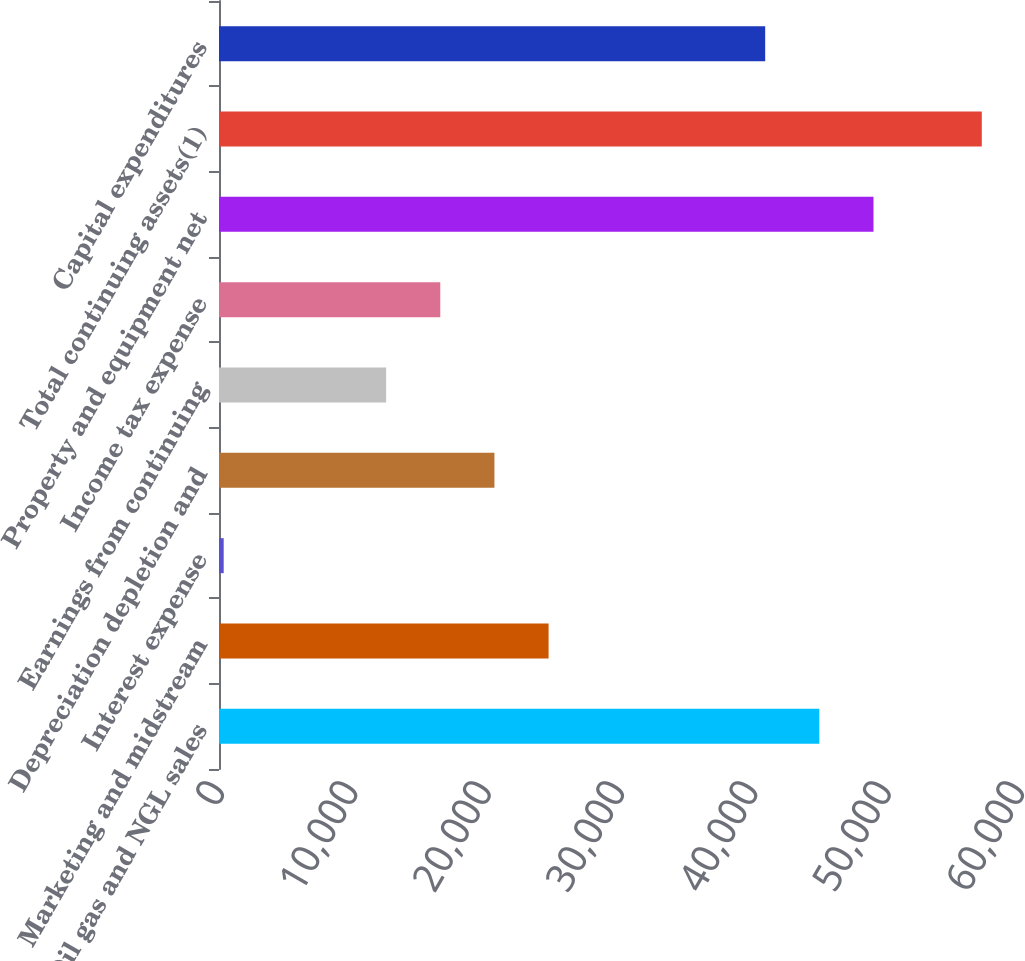Convert chart. <chart><loc_0><loc_0><loc_500><loc_500><bar_chart><fcel>Oil gas and NGL sales<fcel>Marketing and midstream<fcel>Interest expense<fcel>Depreciation depletion and<fcel>Earnings from continuing<fcel>Income tax expense<fcel>Property and equipment net<fcel>Total continuing assets(1)<fcel>Capital expenditures<nl><fcel>45025.2<fcel>24719.2<fcel>352<fcel>20658<fcel>12535.6<fcel>16596.8<fcel>49086.4<fcel>57208.8<fcel>40964<nl></chart> 